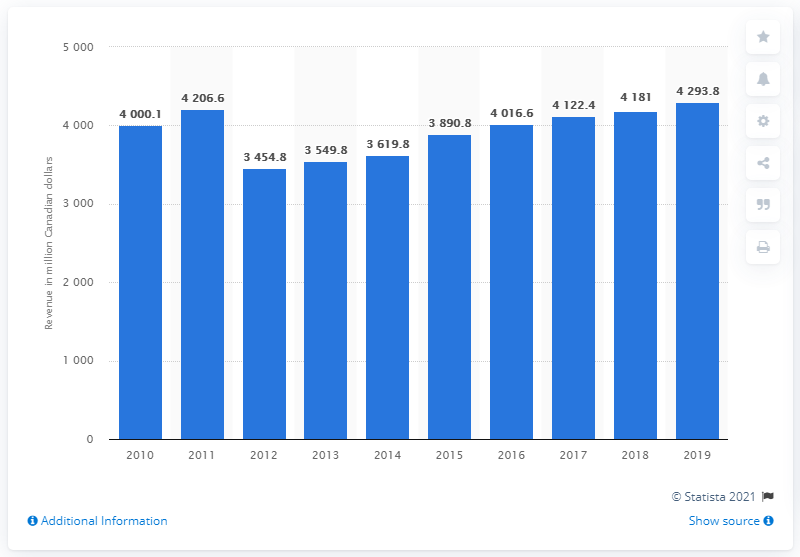Mention a couple of crucial points in this snapshot. In early 2020, approximately 4,293.8% of Quebecor's workforce was temporarily laid off. Quebecor's revenue in 2019 was CAD 4,293.8 million. 